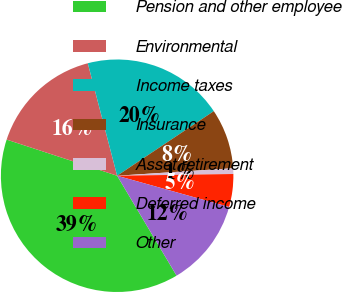Convert chart to OTSL. <chart><loc_0><loc_0><loc_500><loc_500><pie_chart><fcel>Pension and other employee<fcel>Environmental<fcel>Income taxes<fcel>Insurance<fcel>Asset retirement<fcel>Deferred income<fcel>Other<nl><fcel>38.58%<fcel>15.91%<fcel>19.69%<fcel>8.35%<fcel>0.79%<fcel>4.57%<fcel>12.13%<nl></chart> 